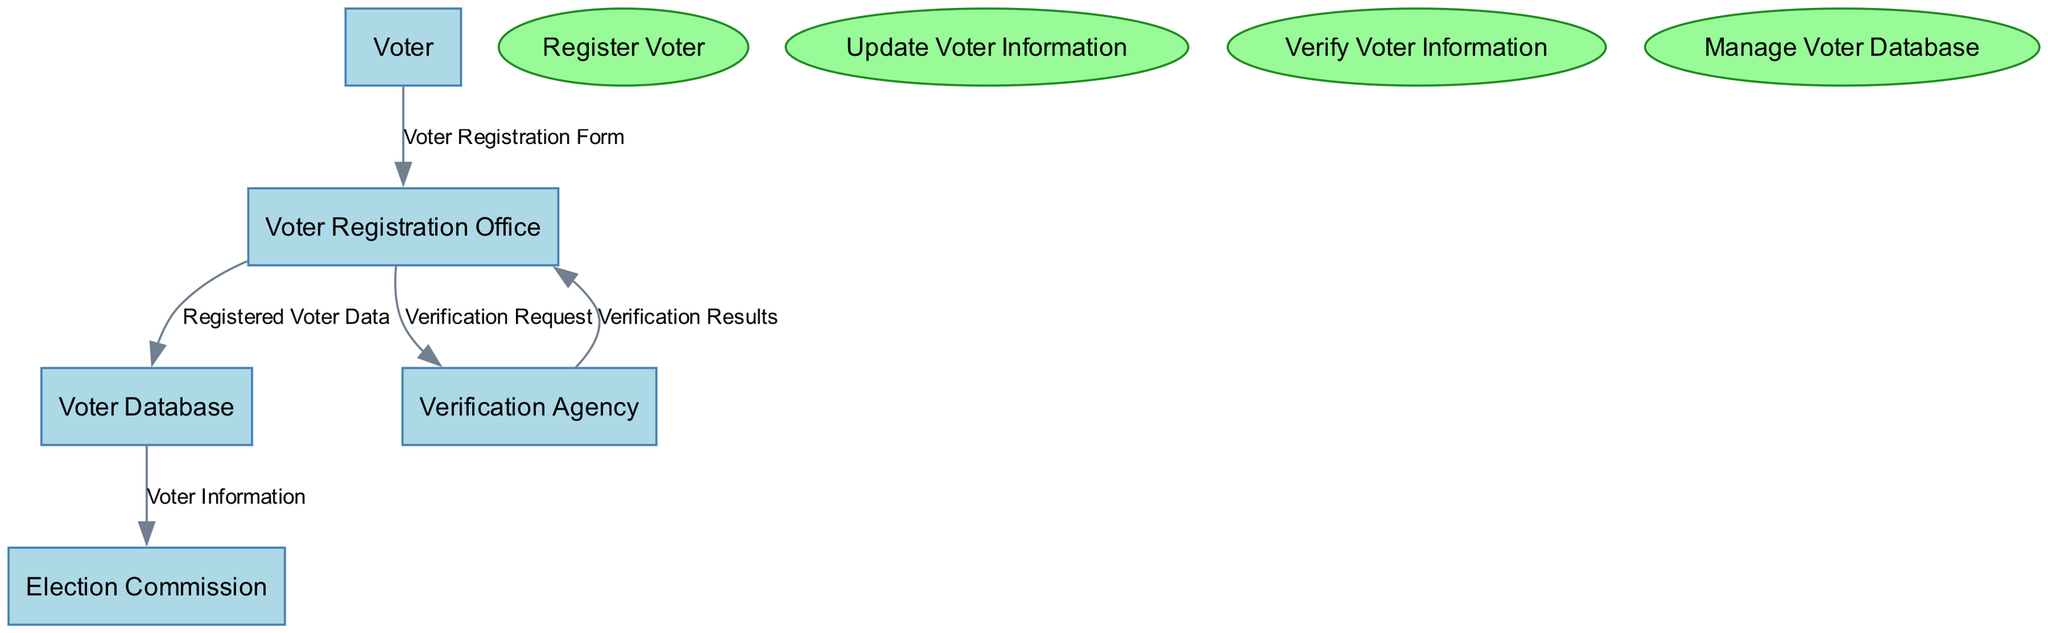What is the name of the process for submitting voter registration information? The diagram contains a node labeled "Register Voter," which indicates this is the process for submitting voter registration information.
Answer: Register Voter How many entities are present in the diagram? By counting the listed entities under the "entities" section of the diagram, there are five: Voter, Voter Registration Office, Voter Database, Election Commission, and Verification Agency.
Answer: Five What data does the Voter Registration Office send to the Voter Database? The Voter Registration Office sends "Registered Voter Data" to the Voter Database according to the labeled data flow in the diagram.
Answer: Registered Voter Data Which entity verifies the accuracy of the voter information? The "Verification Agency" is specifically indicated as the entity responsible for verifying the accuracy of the voter information as detailed in the processes of the diagram.
Answer: Verification Agency Which process is responsible for ensuring the database integrity? The diagram indicates that the "Manage Voter Database" process is responsible for ensuring the integrity and accessibility of the voter database.
Answer: Manage Voter Database What type of data does the Voter send to the Voter Registration Office? The data sent from the Voter to the Voter Registration Office is specified as the "Voter Registration Form" in the diagram's data flow.
Answer: Voter Registration Form How many data flows are present in the diagram? By examining the "dataFlows" section, there are five distinct data flows illustrated, indicating the interactions between various entities and the data exchanged.
Answer: Five What results does the Verification Agency provide to the Voter Registration Office? The diagram shows that the Verification Agency sends back "Verification Results" to the Voter Registration Office as part of the verification process.
Answer: Verification Results 